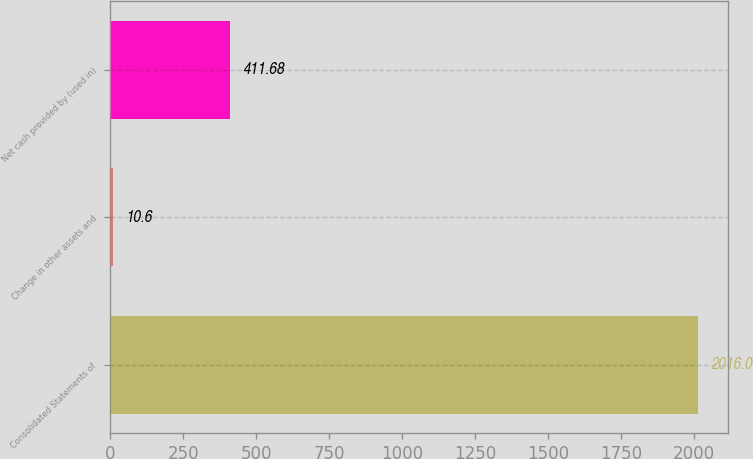<chart> <loc_0><loc_0><loc_500><loc_500><bar_chart><fcel>Consolidated Statements of<fcel>Change in other assets and<fcel>Net cash provided by (used in)<nl><fcel>2016<fcel>10.6<fcel>411.68<nl></chart> 